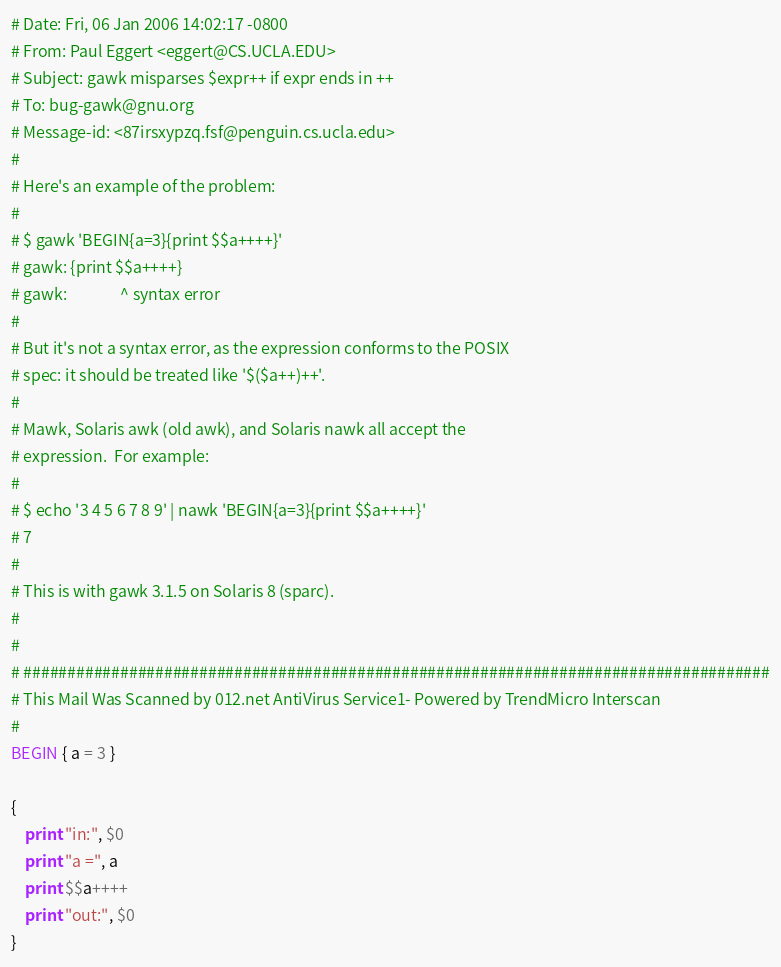Convert code to text. <code><loc_0><loc_0><loc_500><loc_500><_Awk_># Date: Fri, 06 Jan 2006 14:02:17 -0800
# From: Paul Eggert <eggert@CS.UCLA.EDU>
# Subject: gawk misparses $expr++ if expr ends in ++
# To: bug-gawk@gnu.org
# Message-id: <87irsxypzq.fsf@penguin.cs.ucla.edu>
# 
# Here's an example of the problem:
# 
# $ gawk 'BEGIN{a=3}{print $$a++++}'
# gawk: {print $$a++++}
# gawk:               ^ syntax error
# 
# But it's not a syntax error, as the expression conforms to the POSIX
# spec: it should be treated like '$($a++)++'.
# 
# Mawk, Solaris awk (old awk), and Solaris nawk all accept the
# expression.  For example:
# 
# $ echo '3 4 5 6 7 8 9' | nawk 'BEGIN{a=3}{print $$a++++}'
# 7
# 
# This is with gawk 3.1.5 on Solaris 8 (sparc).
# 
# 
# #####################################################################################
# This Mail Was Scanned by 012.net AntiVirus Service1- Powered by TrendMicro Interscan
# 
BEGIN { a = 3 }

{
	print "in:", $0
	print "a =", a
	print $$a++++
	print "out:", $0
}
</code> 